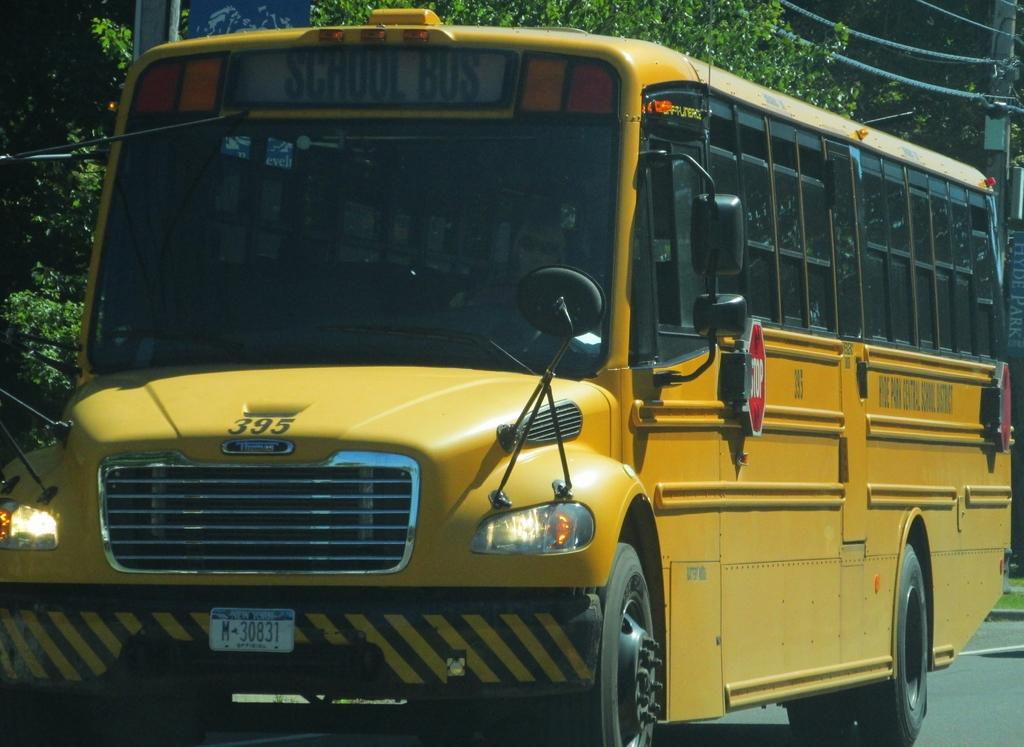What is the main subject of the image? There is a bus in the image. What can be seen in the background of the image? There is a tree in the background of the image. What is located in the top right of the image? There is an electric pole in the top right of the image. Can you see the moon in the image? No, the moon is not visible in the image. Is there anyone adjusting the electric pole in the image? No, there is no one adjusting the electric pole in the image. 